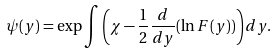<formula> <loc_0><loc_0><loc_500><loc_500>\psi ( y ) = \exp \int \left ( \chi - \frac { 1 } { 2 } \frac { d } { d y } ( \ln F ( y ) ) \right ) d y .</formula> 